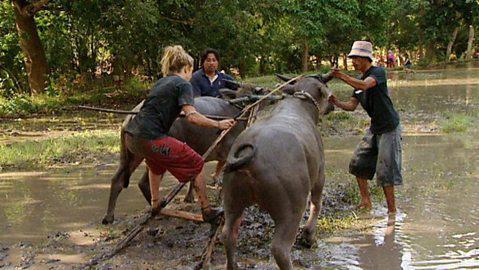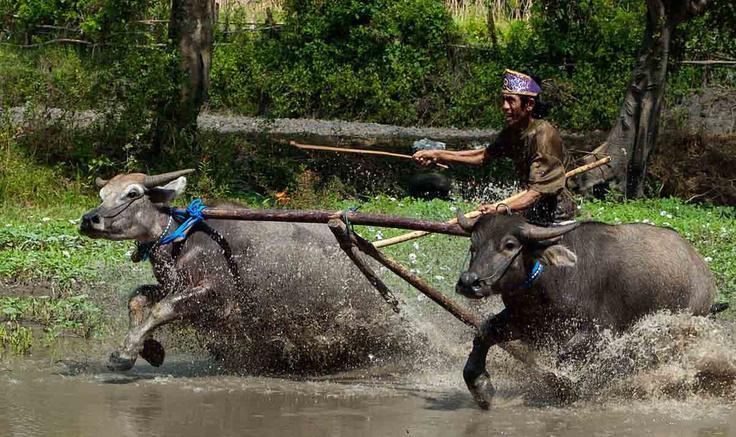The first image is the image on the left, the second image is the image on the right. Considering the images on both sides, is "A man is holding a whip." valid? Answer yes or no. Yes. 